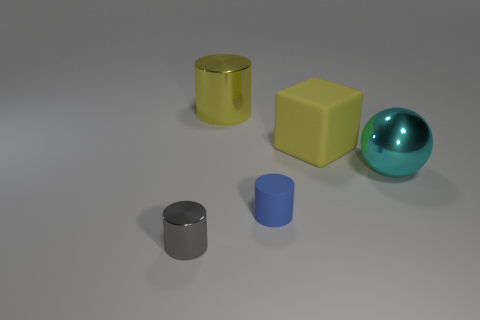Do the object that is right of the large yellow cube and the matte object that is in front of the sphere have the same color?
Your response must be concise. No. Is the number of big yellow rubber blocks left of the gray thing greater than the number of cyan objects?
Ensure brevity in your answer.  No. How many other objects are there of the same color as the rubber block?
Ensure brevity in your answer.  1. There is a shiny cylinder to the right of the gray object; is it the same size as the ball?
Your answer should be very brief. Yes. Is there a cyan ball that has the same size as the gray shiny thing?
Your answer should be compact. No. What color is the matte thing behind the small blue rubber object?
Offer a very short reply. Yellow. There is a metal thing that is left of the small matte cylinder and behind the tiny gray cylinder; what is its shape?
Offer a terse response. Cylinder. What number of small metallic objects have the same shape as the large cyan object?
Offer a very short reply. 0. What number of small green cylinders are there?
Your answer should be very brief. 0. There is a thing that is both behind the cyan ball and right of the small blue object; how big is it?
Offer a terse response. Large. 